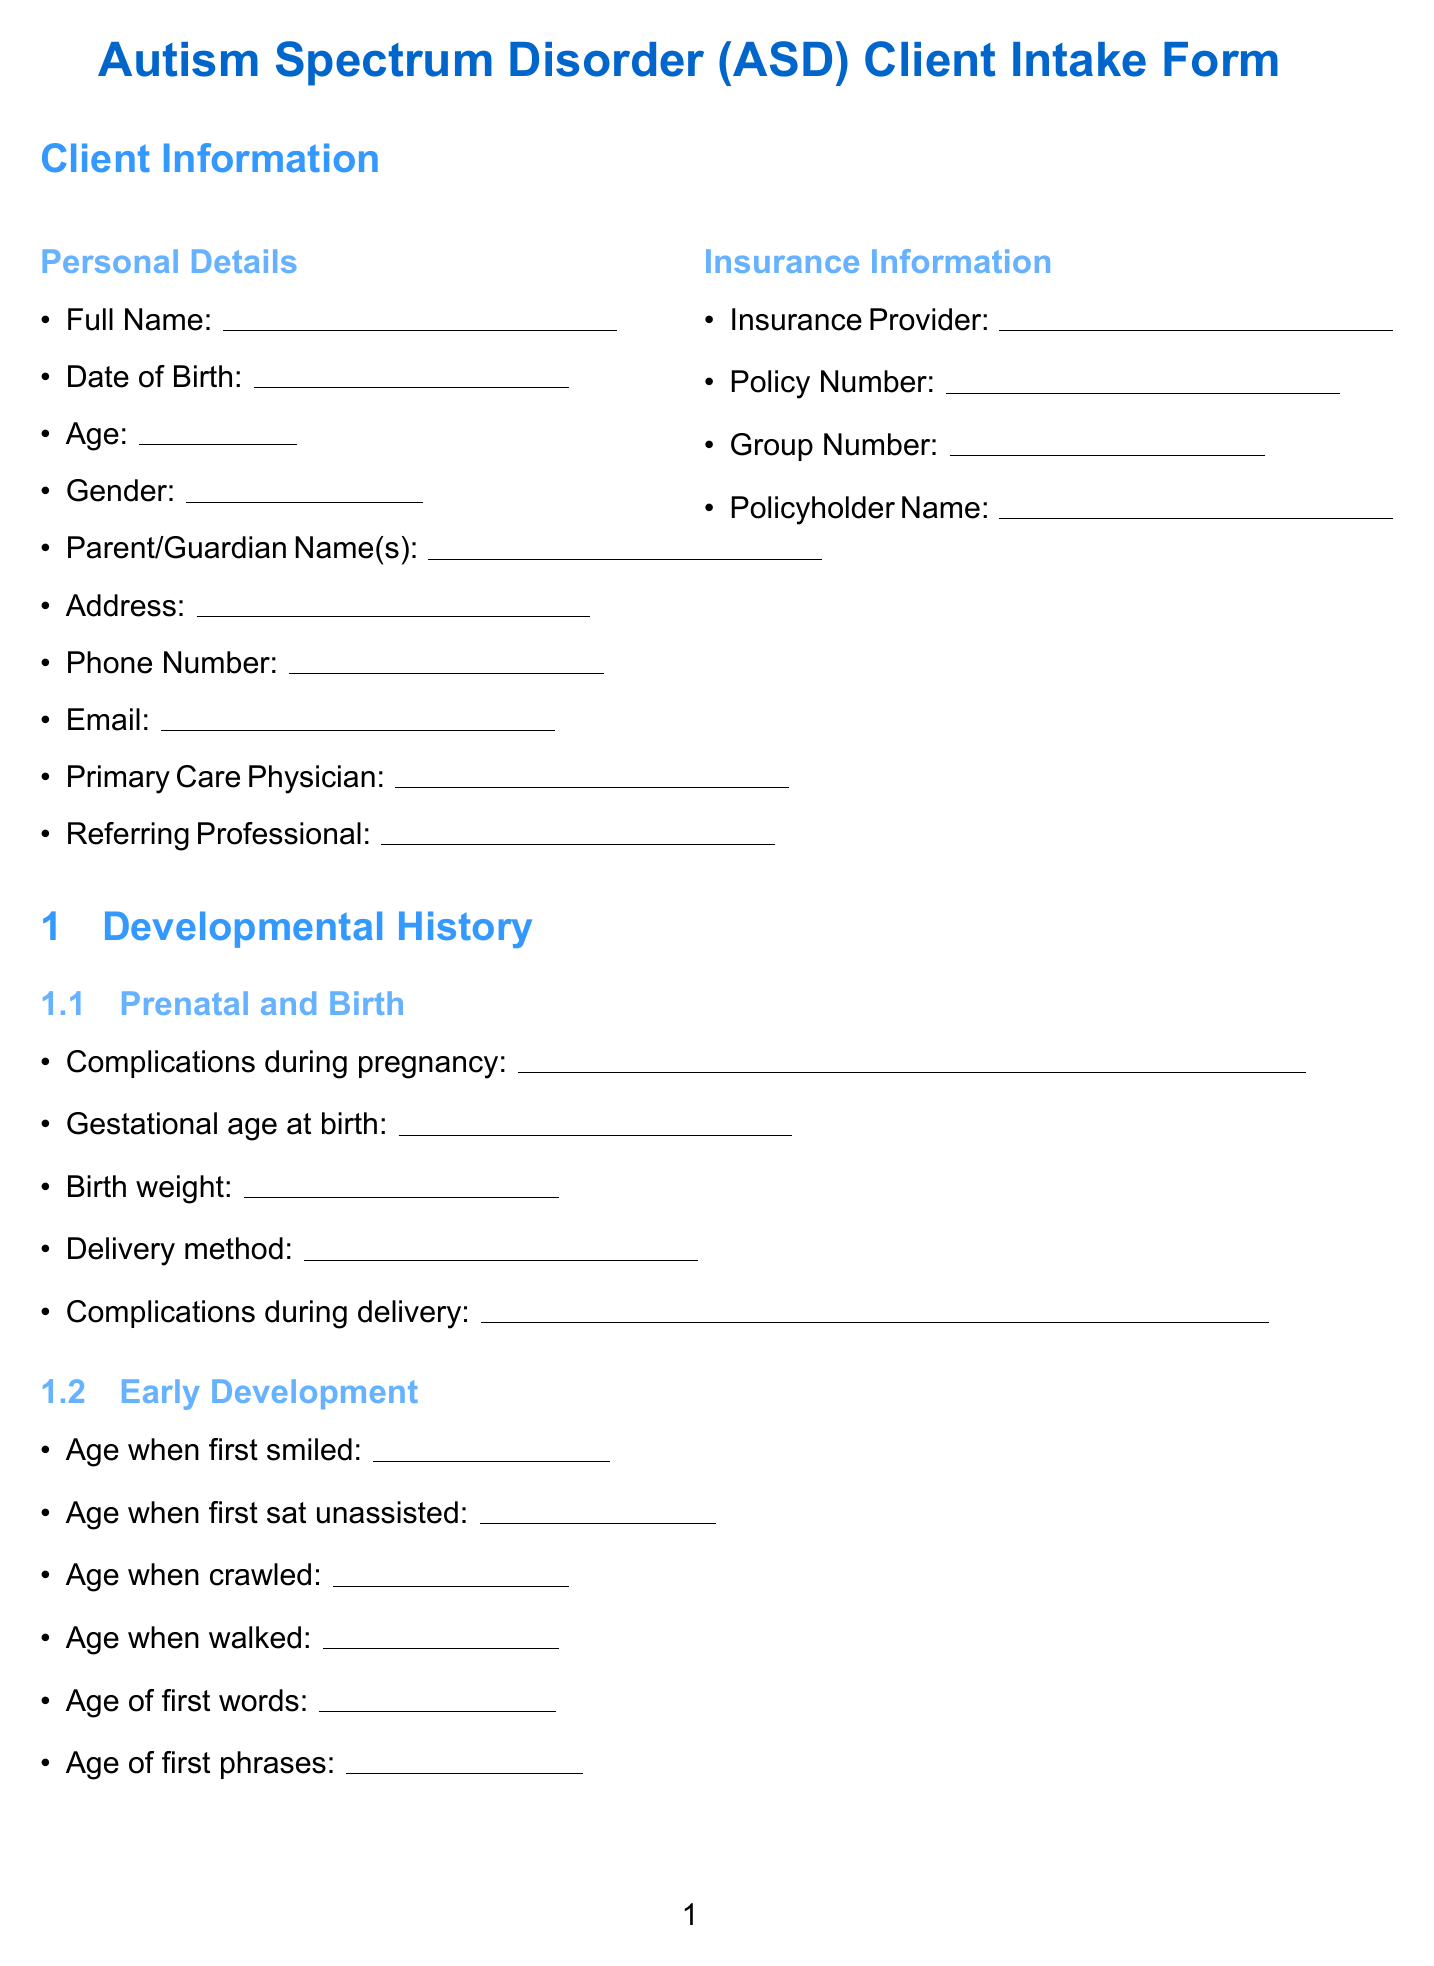What is the title of the document? The title is specified at the beginning of the document as it presents the purpose of the form.
Answer: Autism Spectrum Disorder (ASD) Client Intake Form How many sections are in the developmental history? The sections under developmental history are identified in the document as individual categories of information.
Answer: Four What is listed under the insurance information? The document specifies the items required for insurance information, reflecting typical details needed in such forms.
Answer: Insurance Provider, Policy Number, Group Number, Policyholder Name At what age did the client first walk? The document provides a specific inquiry related to the client's early development milestones, indicating the information requested.
Answer: Age when walked What type of assessment tools are included? The tools listed are essential for assessing ASD, and they are clearly stated in the assessment tools section of the document.
Answer: ADOS-2, ADI-R, CARS, SCQ, Vineland Scales What is the parent/guardian signature line for? This line is essential for obtaining consent for the evaluation process and indicates parental permission.
Answer: Consent for evaluation and treatment How many primary concerns can be specified by parents in the parental concerns section? This section allows parents to identify multiple aspects affecting their child and family dynamics, as detailed in the document.
Answer: One or more What is the age requirement to fill out the form? The age is explicitly requested in the personal details section of the form, ensuring that the client information is clearly captured.
Answer: Age What is the date format expected for the Date of Birth? This is a standard detail requested in client intake forms and direct instruction can be inferred based on expected conventions in documentation.
Answer: MM/DD/YYYY 